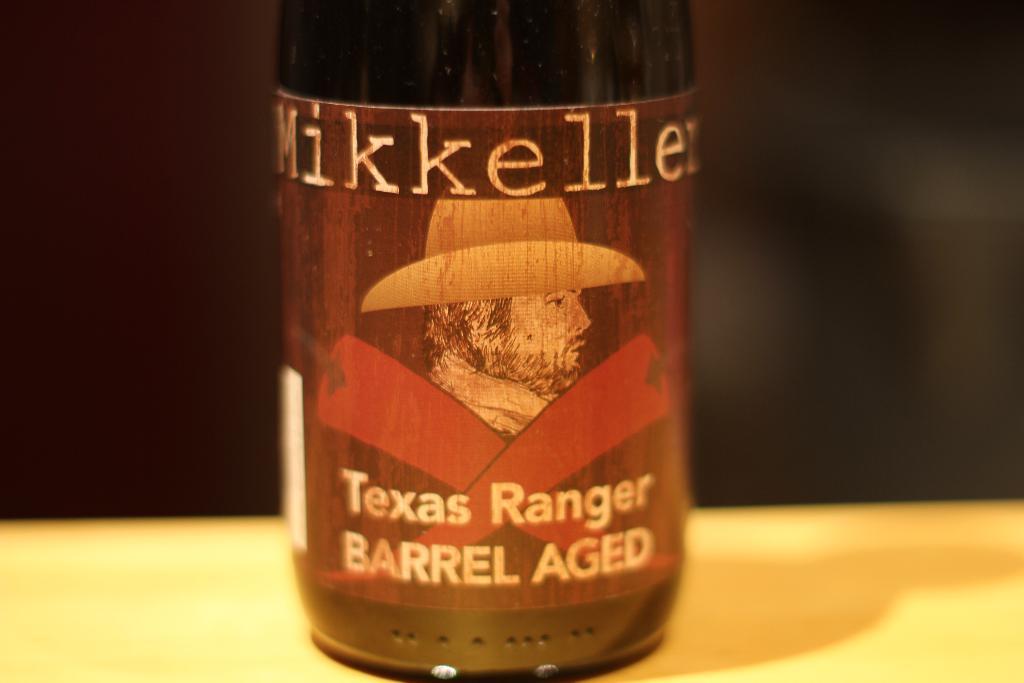What is the brand of the beverage?
Keep it short and to the point. Mikkeller. 